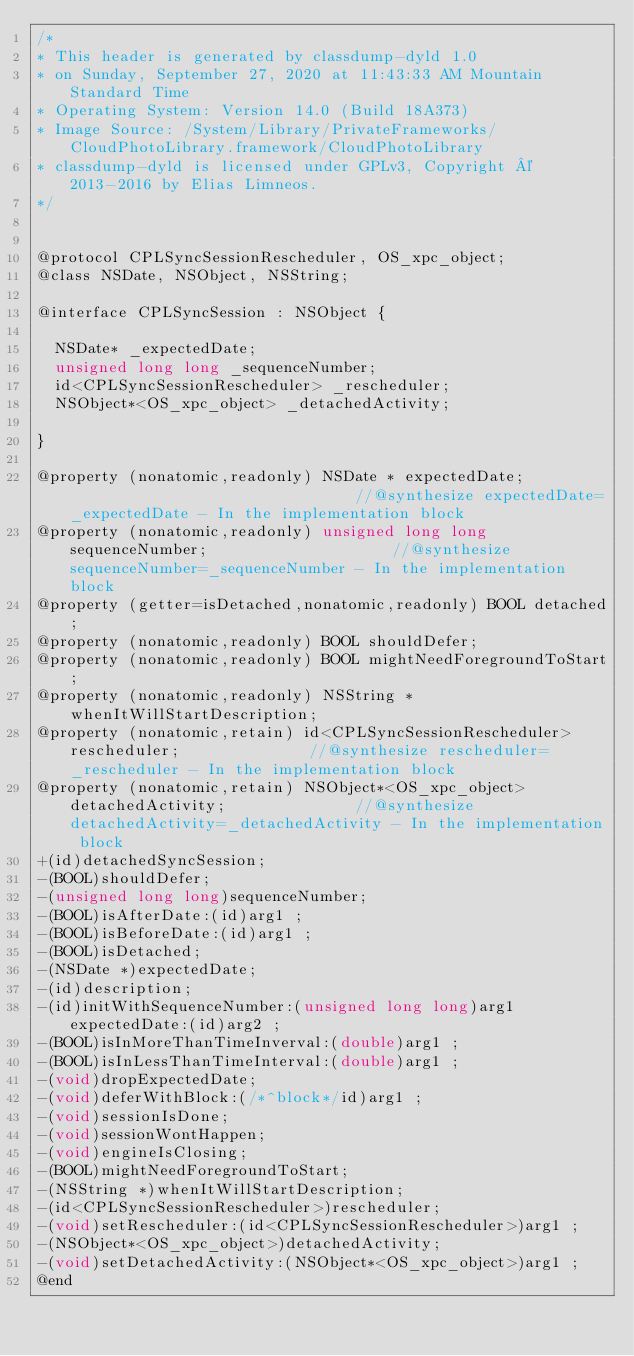Convert code to text. <code><loc_0><loc_0><loc_500><loc_500><_C_>/*
* This header is generated by classdump-dyld 1.0
* on Sunday, September 27, 2020 at 11:43:33 AM Mountain Standard Time
* Operating System: Version 14.0 (Build 18A373)
* Image Source: /System/Library/PrivateFrameworks/CloudPhotoLibrary.framework/CloudPhotoLibrary
* classdump-dyld is licensed under GPLv3, Copyright © 2013-2016 by Elias Limneos.
*/


@protocol CPLSyncSessionRescheduler, OS_xpc_object;
@class NSDate, NSObject, NSString;

@interface CPLSyncSession : NSObject {

	NSDate* _expectedDate;
	unsigned long long _sequenceNumber;
	id<CPLSyncSessionRescheduler> _rescheduler;
	NSObject*<OS_xpc_object> _detachedActivity;

}

@property (nonatomic,readonly) NSDate * expectedDate;                                //@synthesize expectedDate=_expectedDate - In the implementation block
@property (nonatomic,readonly) unsigned long long sequenceNumber;                    //@synthesize sequenceNumber=_sequenceNumber - In the implementation block
@property (getter=isDetached,nonatomic,readonly) BOOL detached; 
@property (nonatomic,readonly) BOOL shouldDefer; 
@property (nonatomic,readonly) BOOL mightNeedForegroundToStart; 
@property (nonatomic,readonly) NSString * whenItWillStartDescription; 
@property (nonatomic,retain) id<CPLSyncSessionRescheduler> rescheduler;              //@synthesize rescheduler=_rescheduler - In the implementation block
@property (nonatomic,retain) NSObject*<OS_xpc_object> detachedActivity;              //@synthesize detachedActivity=_detachedActivity - In the implementation block
+(id)detachedSyncSession;
-(BOOL)shouldDefer;
-(unsigned long long)sequenceNumber;
-(BOOL)isAfterDate:(id)arg1 ;
-(BOOL)isBeforeDate:(id)arg1 ;
-(BOOL)isDetached;
-(NSDate *)expectedDate;
-(id)description;
-(id)initWithSequenceNumber:(unsigned long long)arg1 expectedDate:(id)arg2 ;
-(BOOL)isInMoreThanTimeInverval:(double)arg1 ;
-(BOOL)isInLessThanTimeInterval:(double)arg1 ;
-(void)dropExpectedDate;
-(void)deferWithBlock:(/*^block*/id)arg1 ;
-(void)sessionIsDone;
-(void)sessionWontHappen;
-(void)engineIsClosing;
-(BOOL)mightNeedForegroundToStart;
-(NSString *)whenItWillStartDescription;
-(id<CPLSyncSessionRescheduler>)rescheduler;
-(void)setRescheduler:(id<CPLSyncSessionRescheduler>)arg1 ;
-(NSObject*<OS_xpc_object>)detachedActivity;
-(void)setDetachedActivity:(NSObject*<OS_xpc_object>)arg1 ;
@end

</code> 